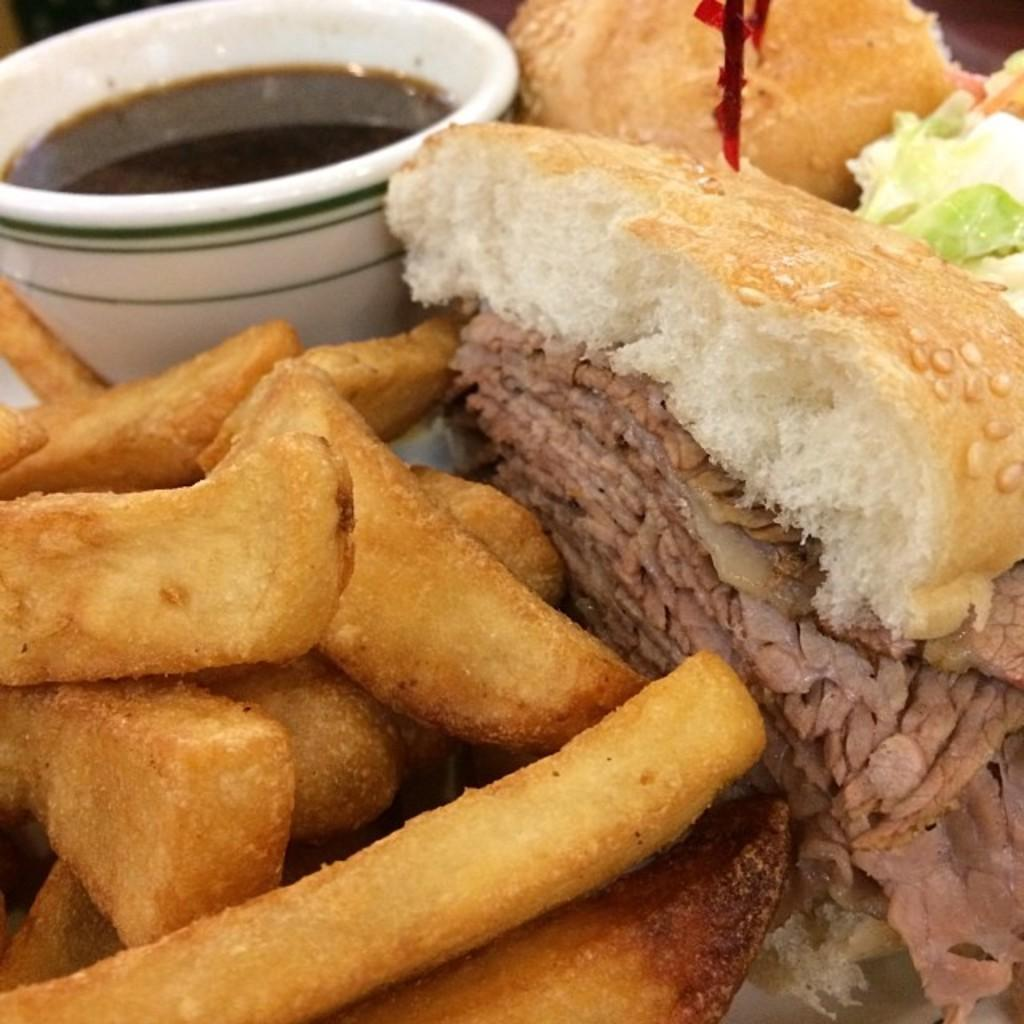What is on the plate in the image? There is food and sauce in the plate. What type of food can be seen in the plate? There are french fries in the plate. What type of expert is giving a lecture in the image? There is no expert or lecture present in the image; it only shows a plate with food and sauce. How many dolls are sitting on the french fries in the image? There are no dolls present in the image; it only shows a plate with food and sauce. 